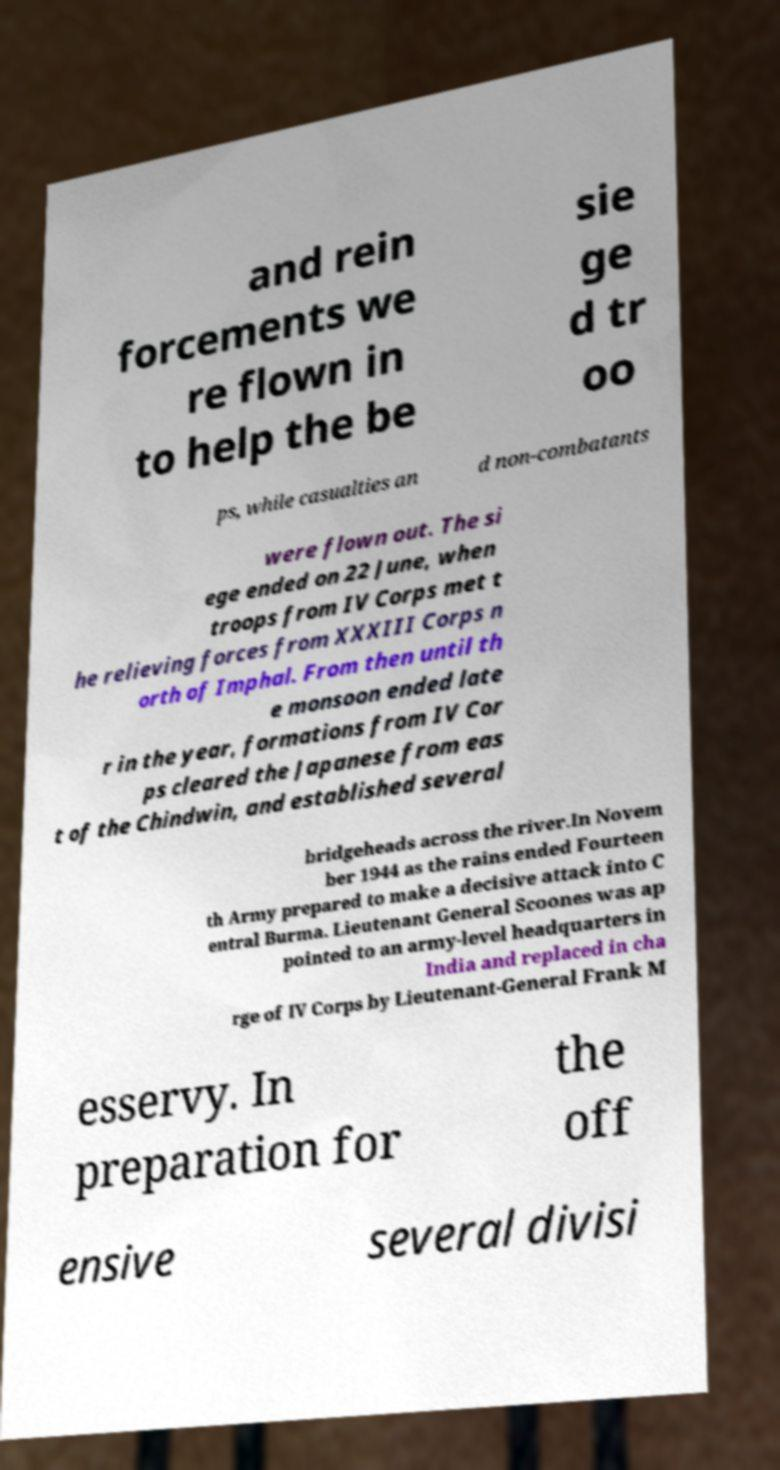For documentation purposes, I need the text within this image transcribed. Could you provide that? and rein forcements we re flown in to help the be sie ge d tr oo ps, while casualties an d non-combatants were flown out. The si ege ended on 22 June, when troops from IV Corps met t he relieving forces from XXXIII Corps n orth of Imphal. From then until th e monsoon ended late r in the year, formations from IV Cor ps cleared the Japanese from eas t of the Chindwin, and established several bridgeheads across the river.In Novem ber 1944 as the rains ended Fourteen th Army prepared to make a decisive attack into C entral Burma. Lieutenant General Scoones was ap pointed to an army-level headquarters in India and replaced in cha rge of IV Corps by Lieutenant-General Frank M esservy. In preparation for the off ensive several divisi 